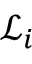Convert formula to latex. <formula><loc_0><loc_0><loc_500><loc_500>\ m a t h s c r { L } _ { i }</formula> 